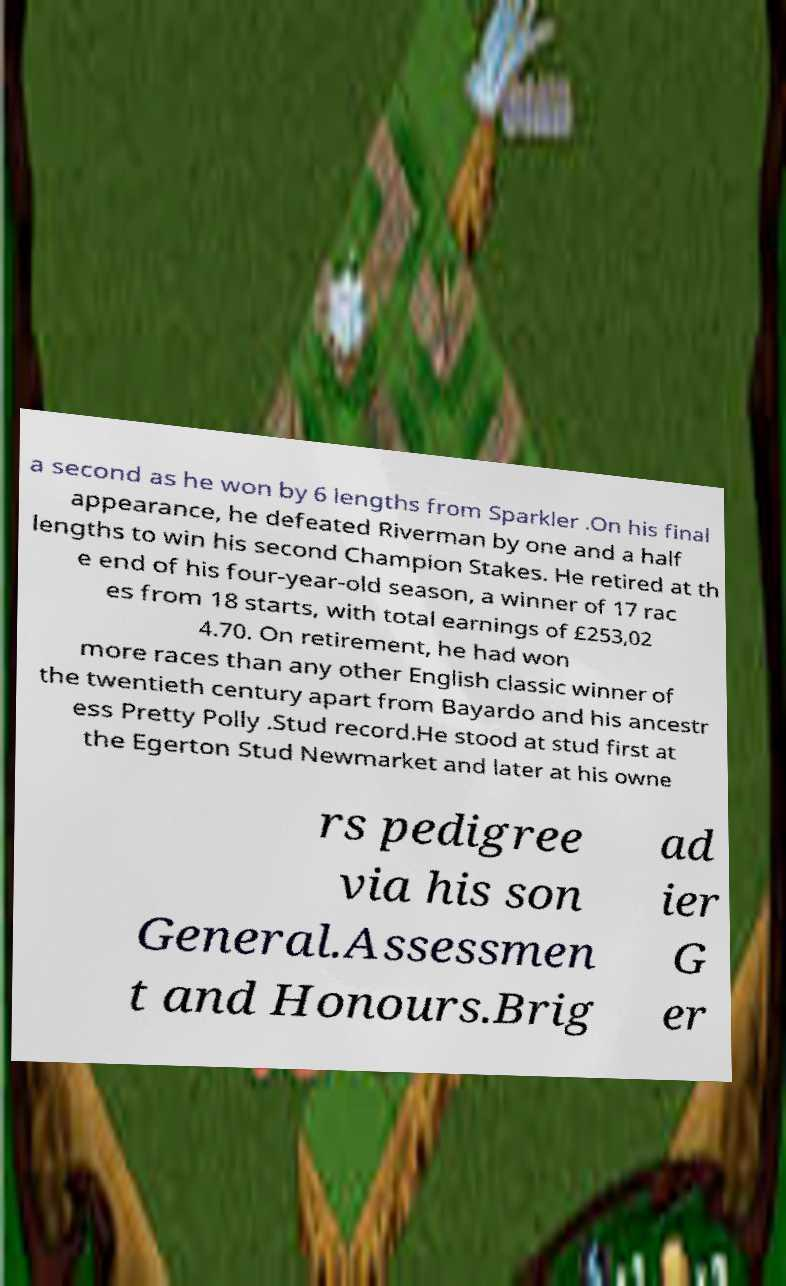Could you extract and type out the text from this image? a second as he won by 6 lengths from Sparkler .On his final appearance, he defeated Riverman by one and a half lengths to win his second Champion Stakes. He retired at th e end of his four-year-old season, a winner of 17 rac es from 18 starts, with total earnings of £253,02 4.70. On retirement, he had won more races than any other English classic winner of the twentieth century apart from Bayardo and his ancestr ess Pretty Polly .Stud record.He stood at stud first at the Egerton Stud Newmarket and later at his owne rs pedigree via his son General.Assessmen t and Honours.Brig ad ier G er 